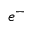Convert formula to latex. <formula><loc_0><loc_0><loc_500><loc_500>e ^ { - }</formula> 